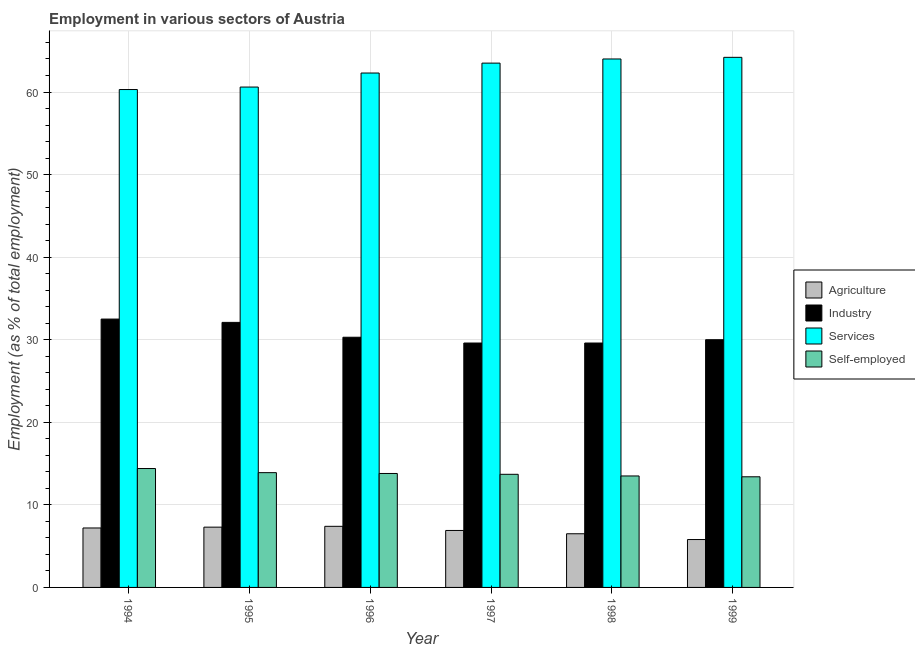How many different coloured bars are there?
Offer a terse response. 4. How many groups of bars are there?
Your answer should be compact. 6. How many bars are there on the 4th tick from the left?
Your response must be concise. 4. How many bars are there on the 4th tick from the right?
Your answer should be compact. 4. What is the label of the 4th group of bars from the left?
Your answer should be compact. 1997. In how many cases, is the number of bars for a given year not equal to the number of legend labels?
Make the answer very short. 0. What is the percentage of workers in agriculture in 1998?
Your response must be concise. 6.5. Across all years, what is the maximum percentage of workers in services?
Make the answer very short. 64.2. Across all years, what is the minimum percentage of workers in services?
Offer a very short reply. 60.3. In which year was the percentage of workers in industry maximum?
Your answer should be compact. 1994. What is the total percentage of workers in agriculture in the graph?
Your answer should be very brief. 41.1. What is the difference between the percentage of self employed workers in 1994 and that in 1995?
Give a very brief answer. 0.5. What is the difference between the percentage of workers in agriculture in 1998 and the percentage of workers in industry in 1999?
Your response must be concise. 0.7. What is the average percentage of workers in industry per year?
Provide a succinct answer. 30.68. What is the ratio of the percentage of workers in industry in 1995 to that in 1997?
Provide a short and direct response. 1.08. Is the percentage of workers in industry in 1996 less than that in 1999?
Make the answer very short. No. What is the difference between the highest and the second highest percentage of workers in agriculture?
Provide a short and direct response. 0.1. Is it the case that in every year, the sum of the percentage of workers in industry and percentage of self employed workers is greater than the sum of percentage of workers in agriculture and percentage of workers in services?
Ensure brevity in your answer.  No. What does the 2nd bar from the left in 1998 represents?
Ensure brevity in your answer.  Industry. What does the 4th bar from the right in 1998 represents?
Offer a very short reply. Agriculture. Is it the case that in every year, the sum of the percentage of workers in agriculture and percentage of workers in industry is greater than the percentage of workers in services?
Offer a terse response. No. How many bars are there?
Give a very brief answer. 24. How many years are there in the graph?
Offer a terse response. 6. What is the difference between two consecutive major ticks on the Y-axis?
Your answer should be very brief. 10. Are the values on the major ticks of Y-axis written in scientific E-notation?
Keep it short and to the point. No. Does the graph contain grids?
Give a very brief answer. Yes. Where does the legend appear in the graph?
Give a very brief answer. Center right. How many legend labels are there?
Give a very brief answer. 4. What is the title of the graph?
Provide a short and direct response. Employment in various sectors of Austria. What is the label or title of the Y-axis?
Offer a very short reply. Employment (as % of total employment). What is the Employment (as % of total employment) in Agriculture in 1994?
Give a very brief answer. 7.2. What is the Employment (as % of total employment) of Industry in 1994?
Offer a terse response. 32.5. What is the Employment (as % of total employment) in Services in 1994?
Provide a short and direct response. 60.3. What is the Employment (as % of total employment) in Self-employed in 1994?
Make the answer very short. 14.4. What is the Employment (as % of total employment) of Agriculture in 1995?
Keep it short and to the point. 7.3. What is the Employment (as % of total employment) in Industry in 1995?
Your answer should be compact. 32.1. What is the Employment (as % of total employment) of Services in 1995?
Your response must be concise. 60.6. What is the Employment (as % of total employment) in Self-employed in 1995?
Give a very brief answer. 13.9. What is the Employment (as % of total employment) in Agriculture in 1996?
Offer a very short reply. 7.4. What is the Employment (as % of total employment) of Industry in 1996?
Give a very brief answer. 30.3. What is the Employment (as % of total employment) in Services in 1996?
Provide a succinct answer. 62.3. What is the Employment (as % of total employment) in Self-employed in 1996?
Your response must be concise. 13.8. What is the Employment (as % of total employment) in Agriculture in 1997?
Keep it short and to the point. 6.9. What is the Employment (as % of total employment) in Industry in 1997?
Provide a short and direct response. 29.6. What is the Employment (as % of total employment) in Services in 1997?
Offer a terse response. 63.5. What is the Employment (as % of total employment) of Self-employed in 1997?
Keep it short and to the point. 13.7. What is the Employment (as % of total employment) of Industry in 1998?
Provide a succinct answer. 29.6. What is the Employment (as % of total employment) in Agriculture in 1999?
Your answer should be very brief. 5.8. What is the Employment (as % of total employment) in Industry in 1999?
Provide a succinct answer. 30. What is the Employment (as % of total employment) of Services in 1999?
Your response must be concise. 64.2. What is the Employment (as % of total employment) of Self-employed in 1999?
Offer a very short reply. 13.4. Across all years, what is the maximum Employment (as % of total employment) in Agriculture?
Provide a short and direct response. 7.4. Across all years, what is the maximum Employment (as % of total employment) of Industry?
Ensure brevity in your answer.  32.5. Across all years, what is the maximum Employment (as % of total employment) in Services?
Provide a short and direct response. 64.2. Across all years, what is the maximum Employment (as % of total employment) of Self-employed?
Provide a short and direct response. 14.4. Across all years, what is the minimum Employment (as % of total employment) of Agriculture?
Provide a succinct answer. 5.8. Across all years, what is the minimum Employment (as % of total employment) of Industry?
Provide a short and direct response. 29.6. Across all years, what is the minimum Employment (as % of total employment) of Services?
Ensure brevity in your answer.  60.3. Across all years, what is the minimum Employment (as % of total employment) in Self-employed?
Offer a terse response. 13.4. What is the total Employment (as % of total employment) in Agriculture in the graph?
Ensure brevity in your answer.  41.1. What is the total Employment (as % of total employment) in Industry in the graph?
Offer a very short reply. 184.1. What is the total Employment (as % of total employment) of Services in the graph?
Your response must be concise. 374.9. What is the total Employment (as % of total employment) in Self-employed in the graph?
Offer a terse response. 82.7. What is the difference between the Employment (as % of total employment) in Agriculture in 1994 and that in 1995?
Keep it short and to the point. -0.1. What is the difference between the Employment (as % of total employment) in Services in 1994 and that in 1995?
Your answer should be very brief. -0.3. What is the difference between the Employment (as % of total employment) of Agriculture in 1994 and that in 1996?
Offer a terse response. -0.2. What is the difference between the Employment (as % of total employment) of Services in 1994 and that in 1996?
Your answer should be compact. -2. What is the difference between the Employment (as % of total employment) of Industry in 1994 and that in 1997?
Offer a very short reply. 2.9. What is the difference between the Employment (as % of total employment) in Services in 1994 and that in 1997?
Your response must be concise. -3.2. What is the difference between the Employment (as % of total employment) in Self-employed in 1994 and that in 1997?
Offer a terse response. 0.7. What is the difference between the Employment (as % of total employment) in Industry in 1994 and that in 1999?
Keep it short and to the point. 2.5. What is the difference between the Employment (as % of total employment) of Services in 1994 and that in 1999?
Make the answer very short. -3.9. What is the difference between the Employment (as % of total employment) of Self-employed in 1994 and that in 1999?
Give a very brief answer. 1. What is the difference between the Employment (as % of total employment) in Services in 1995 and that in 1996?
Provide a succinct answer. -1.7. What is the difference between the Employment (as % of total employment) in Self-employed in 1995 and that in 1996?
Offer a terse response. 0.1. What is the difference between the Employment (as % of total employment) of Services in 1995 and that in 1997?
Make the answer very short. -2.9. What is the difference between the Employment (as % of total employment) of Services in 1995 and that in 1998?
Give a very brief answer. -3.4. What is the difference between the Employment (as % of total employment) in Agriculture in 1995 and that in 1999?
Your answer should be compact. 1.5. What is the difference between the Employment (as % of total employment) in Self-employed in 1995 and that in 1999?
Keep it short and to the point. 0.5. What is the difference between the Employment (as % of total employment) in Agriculture in 1996 and that in 1997?
Offer a very short reply. 0.5. What is the difference between the Employment (as % of total employment) of Agriculture in 1996 and that in 1998?
Make the answer very short. 0.9. What is the difference between the Employment (as % of total employment) in Self-employed in 1996 and that in 1998?
Offer a very short reply. 0.3. What is the difference between the Employment (as % of total employment) of Agriculture in 1996 and that in 1999?
Provide a short and direct response. 1.6. What is the difference between the Employment (as % of total employment) in Services in 1996 and that in 1999?
Your response must be concise. -1.9. What is the difference between the Employment (as % of total employment) of Self-employed in 1997 and that in 1998?
Give a very brief answer. 0.2. What is the difference between the Employment (as % of total employment) of Agriculture in 1997 and that in 1999?
Your answer should be very brief. 1.1. What is the difference between the Employment (as % of total employment) of Industry in 1997 and that in 1999?
Offer a very short reply. -0.4. What is the difference between the Employment (as % of total employment) of Industry in 1998 and that in 1999?
Offer a terse response. -0.4. What is the difference between the Employment (as % of total employment) in Self-employed in 1998 and that in 1999?
Give a very brief answer. 0.1. What is the difference between the Employment (as % of total employment) of Agriculture in 1994 and the Employment (as % of total employment) of Industry in 1995?
Give a very brief answer. -24.9. What is the difference between the Employment (as % of total employment) in Agriculture in 1994 and the Employment (as % of total employment) in Services in 1995?
Provide a short and direct response. -53.4. What is the difference between the Employment (as % of total employment) of Industry in 1994 and the Employment (as % of total employment) of Services in 1995?
Your response must be concise. -28.1. What is the difference between the Employment (as % of total employment) in Industry in 1994 and the Employment (as % of total employment) in Self-employed in 1995?
Your answer should be very brief. 18.6. What is the difference between the Employment (as % of total employment) in Services in 1994 and the Employment (as % of total employment) in Self-employed in 1995?
Ensure brevity in your answer.  46.4. What is the difference between the Employment (as % of total employment) of Agriculture in 1994 and the Employment (as % of total employment) of Industry in 1996?
Provide a short and direct response. -23.1. What is the difference between the Employment (as % of total employment) of Agriculture in 1994 and the Employment (as % of total employment) of Services in 1996?
Keep it short and to the point. -55.1. What is the difference between the Employment (as % of total employment) in Industry in 1994 and the Employment (as % of total employment) in Services in 1996?
Make the answer very short. -29.8. What is the difference between the Employment (as % of total employment) of Industry in 1994 and the Employment (as % of total employment) of Self-employed in 1996?
Give a very brief answer. 18.7. What is the difference between the Employment (as % of total employment) in Services in 1994 and the Employment (as % of total employment) in Self-employed in 1996?
Your response must be concise. 46.5. What is the difference between the Employment (as % of total employment) of Agriculture in 1994 and the Employment (as % of total employment) of Industry in 1997?
Provide a succinct answer. -22.4. What is the difference between the Employment (as % of total employment) of Agriculture in 1994 and the Employment (as % of total employment) of Services in 1997?
Provide a short and direct response. -56.3. What is the difference between the Employment (as % of total employment) in Industry in 1994 and the Employment (as % of total employment) in Services in 1997?
Keep it short and to the point. -31. What is the difference between the Employment (as % of total employment) in Industry in 1994 and the Employment (as % of total employment) in Self-employed in 1997?
Offer a very short reply. 18.8. What is the difference between the Employment (as % of total employment) in Services in 1994 and the Employment (as % of total employment) in Self-employed in 1997?
Ensure brevity in your answer.  46.6. What is the difference between the Employment (as % of total employment) in Agriculture in 1994 and the Employment (as % of total employment) in Industry in 1998?
Your answer should be compact. -22.4. What is the difference between the Employment (as % of total employment) in Agriculture in 1994 and the Employment (as % of total employment) in Services in 1998?
Your answer should be very brief. -56.8. What is the difference between the Employment (as % of total employment) of Industry in 1994 and the Employment (as % of total employment) of Services in 1998?
Provide a succinct answer. -31.5. What is the difference between the Employment (as % of total employment) of Services in 1994 and the Employment (as % of total employment) of Self-employed in 1998?
Provide a short and direct response. 46.8. What is the difference between the Employment (as % of total employment) in Agriculture in 1994 and the Employment (as % of total employment) in Industry in 1999?
Your answer should be very brief. -22.8. What is the difference between the Employment (as % of total employment) in Agriculture in 1994 and the Employment (as % of total employment) in Services in 1999?
Keep it short and to the point. -57. What is the difference between the Employment (as % of total employment) in Industry in 1994 and the Employment (as % of total employment) in Services in 1999?
Make the answer very short. -31.7. What is the difference between the Employment (as % of total employment) in Services in 1994 and the Employment (as % of total employment) in Self-employed in 1999?
Offer a terse response. 46.9. What is the difference between the Employment (as % of total employment) in Agriculture in 1995 and the Employment (as % of total employment) in Industry in 1996?
Make the answer very short. -23. What is the difference between the Employment (as % of total employment) in Agriculture in 1995 and the Employment (as % of total employment) in Services in 1996?
Provide a succinct answer. -55. What is the difference between the Employment (as % of total employment) of Agriculture in 1995 and the Employment (as % of total employment) of Self-employed in 1996?
Offer a very short reply. -6.5. What is the difference between the Employment (as % of total employment) of Industry in 1995 and the Employment (as % of total employment) of Services in 1996?
Offer a terse response. -30.2. What is the difference between the Employment (as % of total employment) of Industry in 1995 and the Employment (as % of total employment) of Self-employed in 1996?
Give a very brief answer. 18.3. What is the difference between the Employment (as % of total employment) in Services in 1995 and the Employment (as % of total employment) in Self-employed in 1996?
Make the answer very short. 46.8. What is the difference between the Employment (as % of total employment) in Agriculture in 1995 and the Employment (as % of total employment) in Industry in 1997?
Provide a short and direct response. -22.3. What is the difference between the Employment (as % of total employment) of Agriculture in 1995 and the Employment (as % of total employment) of Services in 1997?
Provide a succinct answer. -56.2. What is the difference between the Employment (as % of total employment) of Agriculture in 1995 and the Employment (as % of total employment) of Self-employed in 1997?
Make the answer very short. -6.4. What is the difference between the Employment (as % of total employment) of Industry in 1995 and the Employment (as % of total employment) of Services in 1997?
Offer a very short reply. -31.4. What is the difference between the Employment (as % of total employment) of Services in 1995 and the Employment (as % of total employment) of Self-employed in 1997?
Offer a terse response. 46.9. What is the difference between the Employment (as % of total employment) of Agriculture in 1995 and the Employment (as % of total employment) of Industry in 1998?
Give a very brief answer. -22.3. What is the difference between the Employment (as % of total employment) of Agriculture in 1995 and the Employment (as % of total employment) of Services in 1998?
Provide a succinct answer. -56.7. What is the difference between the Employment (as % of total employment) of Industry in 1995 and the Employment (as % of total employment) of Services in 1998?
Your answer should be very brief. -31.9. What is the difference between the Employment (as % of total employment) of Services in 1995 and the Employment (as % of total employment) of Self-employed in 1998?
Provide a short and direct response. 47.1. What is the difference between the Employment (as % of total employment) in Agriculture in 1995 and the Employment (as % of total employment) in Industry in 1999?
Provide a succinct answer. -22.7. What is the difference between the Employment (as % of total employment) of Agriculture in 1995 and the Employment (as % of total employment) of Services in 1999?
Provide a short and direct response. -56.9. What is the difference between the Employment (as % of total employment) in Agriculture in 1995 and the Employment (as % of total employment) in Self-employed in 1999?
Provide a succinct answer. -6.1. What is the difference between the Employment (as % of total employment) in Industry in 1995 and the Employment (as % of total employment) in Services in 1999?
Provide a short and direct response. -32.1. What is the difference between the Employment (as % of total employment) of Services in 1995 and the Employment (as % of total employment) of Self-employed in 1999?
Offer a very short reply. 47.2. What is the difference between the Employment (as % of total employment) in Agriculture in 1996 and the Employment (as % of total employment) in Industry in 1997?
Provide a succinct answer. -22.2. What is the difference between the Employment (as % of total employment) of Agriculture in 1996 and the Employment (as % of total employment) of Services in 1997?
Your response must be concise. -56.1. What is the difference between the Employment (as % of total employment) in Industry in 1996 and the Employment (as % of total employment) in Services in 1997?
Give a very brief answer. -33.2. What is the difference between the Employment (as % of total employment) in Services in 1996 and the Employment (as % of total employment) in Self-employed in 1997?
Keep it short and to the point. 48.6. What is the difference between the Employment (as % of total employment) in Agriculture in 1996 and the Employment (as % of total employment) in Industry in 1998?
Your answer should be very brief. -22.2. What is the difference between the Employment (as % of total employment) in Agriculture in 1996 and the Employment (as % of total employment) in Services in 1998?
Offer a very short reply. -56.6. What is the difference between the Employment (as % of total employment) of Agriculture in 1996 and the Employment (as % of total employment) of Self-employed in 1998?
Your answer should be compact. -6.1. What is the difference between the Employment (as % of total employment) of Industry in 1996 and the Employment (as % of total employment) of Services in 1998?
Your answer should be compact. -33.7. What is the difference between the Employment (as % of total employment) of Services in 1996 and the Employment (as % of total employment) of Self-employed in 1998?
Keep it short and to the point. 48.8. What is the difference between the Employment (as % of total employment) in Agriculture in 1996 and the Employment (as % of total employment) in Industry in 1999?
Offer a terse response. -22.6. What is the difference between the Employment (as % of total employment) in Agriculture in 1996 and the Employment (as % of total employment) in Services in 1999?
Provide a short and direct response. -56.8. What is the difference between the Employment (as % of total employment) in Agriculture in 1996 and the Employment (as % of total employment) in Self-employed in 1999?
Your answer should be very brief. -6. What is the difference between the Employment (as % of total employment) in Industry in 1996 and the Employment (as % of total employment) in Services in 1999?
Make the answer very short. -33.9. What is the difference between the Employment (as % of total employment) of Services in 1996 and the Employment (as % of total employment) of Self-employed in 1999?
Make the answer very short. 48.9. What is the difference between the Employment (as % of total employment) in Agriculture in 1997 and the Employment (as % of total employment) in Industry in 1998?
Offer a very short reply. -22.7. What is the difference between the Employment (as % of total employment) of Agriculture in 1997 and the Employment (as % of total employment) of Services in 1998?
Offer a terse response. -57.1. What is the difference between the Employment (as % of total employment) in Industry in 1997 and the Employment (as % of total employment) in Services in 1998?
Your answer should be compact. -34.4. What is the difference between the Employment (as % of total employment) in Industry in 1997 and the Employment (as % of total employment) in Self-employed in 1998?
Give a very brief answer. 16.1. What is the difference between the Employment (as % of total employment) of Services in 1997 and the Employment (as % of total employment) of Self-employed in 1998?
Provide a succinct answer. 50. What is the difference between the Employment (as % of total employment) in Agriculture in 1997 and the Employment (as % of total employment) in Industry in 1999?
Ensure brevity in your answer.  -23.1. What is the difference between the Employment (as % of total employment) of Agriculture in 1997 and the Employment (as % of total employment) of Services in 1999?
Provide a succinct answer. -57.3. What is the difference between the Employment (as % of total employment) of Agriculture in 1997 and the Employment (as % of total employment) of Self-employed in 1999?
Offer a terse response. -6.5. What is the difference between the Employment (as % of total employment) of Industry in 1997 and the Employment (as % of total employment) of Services in 1999?
Offer a very short reply. -34.6. What is the difference between the Employment (as % of total employment) in Industry in 1997 and the Employment (as % of total employment) in Self-employed in 1999?
Give a very brief answer. 16.2. What is the difference between the Employment (as % of total employment) of Services in 1997 and the Employment (as % of total employment) of Self-employed in 1999?
Your response must be concise. 50.1. What is the difference between the Employment (as % of total employment) in Agriculture in 1998 and the Employment (as % of total employment) in Industry in 1999?
Your answer should be compact. -23.5. What is the difference between the Employment (as % of total employment) of Agriculture in 1998 and the Employment (as % of total employment) of Services in 1999?
Offer a very short reply. -57.7. What is the difference between the Employment (as % of total employment) in Industry in 1998 and the Employment (as % of total employment) in Services in 1999?
Give a very brief answer. -34.6. What is the difference between the Employment (as % of total employment) of Industry in 1998 and the Employment (as % of total employment) of Self-employed in 1999?
Keep it short and to the point. 16.2. What is the difference between the Employment (as % of total employment) of Services in 1998 and the Employment (as % of total employment) of Self-employed in 1999?
Ensure brevity in your answer.  50.6. What is the average Employment (as % of total employment) in Agriculture per year?
Ensure brevity in your answer.  6.85. What is the average Employment (as % of total employment) in Industry per year?
Your response must be concise. 30.68. What is the average Employment (as % of total employment) of Services per year?
Your answer should be very brief. 62.48. What is the average Employment (as % of total employment) in Self-employed per year?
Your response must be concise. 13.78. In the year 1994, what is the difference between the Employment (as % of total employment) in Agriculture and Employment (as % of total employment) in Industry?
Provide a short and direct response. -25.3. In the year 1994, what is the difference between the Employment (as % of total employment) of Agriculture and Employment (as % of total employment) of Services?
Make the answer very short. -53.1. In the year 1994, what is the difference between the Employment (as % of total employment) in Agriculture and Employment (as % of total employment) in Self-employed?
Your response must be concise. -7.2. In the year 1994, what is the difference between the Employment (as % of total employment) in Industry and Employment (as % of total employment) in Services?
Keep it short and to the point. -27.8. In the year 1994, what is the difference between the Employment (as % of total employment) in Industry and Employment (as % of total employment) in Self-employed?
Keep it short and to the point. 18.1. In the year 1994, what is the difference between the Employment (as % of total employment) in Services and Employment (as % of total employment) in Self-employed?
Offer a terse response. 45.9. In the year 1995, what is the difference between the Employment (as % of total employment) in Agriculture and Employment (as % of total employment) in Industry?
Your answer should be very brief. -24.8. In the year 1995, what is the difference between the Employment (as % of total employment) in Agriculture and Employment (as % of total employment) in Services?
Make the answer very short. -53.3. In the year 1995, what is the difference between the Employment (as % of total employment) in Agriculture and Employment (as % of total employment) in Self-employed?
Provide a succinct answer. -6.6. In the year 1995, what is the difference between the Employment (as % of total employment) in Industry and Employment (as % of total employment) in Services?
Provide a short and direct response. -28.5. In the year 1995, what is the difference between the Employment (as % of total employment) in Industry and Employment (as % of total employment) in Self-employed?
Make the answer very short. 18.2. In the year 1995, what is the difference between the Employment (as % of total employment) of Services and Employment (as % of total employment) of Self-employed?
Your answer should be very brief. 46.7. In the year 1996, what is the difference between the Employment (as % of total employment) of Agriculture and Employment (as % of total employment) of Industry?
Make the answer very short. -22.9. In the year 1996, what is the difference between the Employment (as % of total employment) in Agriculture and Employment (as % of total employment) in Services?
Offer a terse response. -54.9. In the year 1996, what is the difference between the Employment (as % of total employment) of Agriculture and Employment (as % of total employment) of Self-employed?
Your response must be concise. -6.4. In the year 1996, what is the difference between the Employment (as % of total employment) in Industry and Employment (as % of total employment) in Services?
Offer a terse response. -32. In the year 1996, what is the difference between the Employment (as % of total employment) in Services and Employment (as % of total employment) in Self-employed?
Offer a terse response. 48.5. In the year 1997, what is the difference between the Employment (as % of total employment) of Agriculture and Employment (as % of total employment) of Industry?
Offer a very short reply. -22.7. In the year 1997, what is the difference between the Employment (as % of total employment) of Agriculture and Employment (as % of total employment) of Services?
Offer a very short reply. -56.6. In the year 1997, what is the difference between the Employment (as % of total employment) of Industry and Employment (as % of total employment) of Services?
Ensure brevity in your answer.  -33.9. In the year 1997, what is the difference between the Employment (as % of total employment) of Industry and Employment (as % of total employment) of Self-employed?
Give a very brief answer. 15.9. In the year 1997, what is the difference between the Employment (as % of total employment) in Services and Employment (as % of total employment) in Self-employed?
Your answer should be compact. 49.8. In the year 1998, what is the difference between the Employment (as % of total employment) of Agriculture and Employment (as % of total employment) of Industry?
Your answer should be very brief. -23.1. In the year 1998, what is the difference between the Employment (as % of total employment) in Agriculture and Employment (as % of total employment) in Services?
Your response must be concise. -57.5. In the year 1998, what is the difference between the Employment (as % of total employment) of Industry and Employment (as % of total employment) of Services?
Ensure brevity in your answer.  -34.4. In the year 1998, what is the difference between the Employment (as % of total employment) of Industry and Employment (as % of total employment) of Self-employed?
Offer a terse response. 16.1. In the year 1998, what is the difference between the Employment (as % of total employment) in Services and Employment (as % of total employment) in Self-employed?
Offer a terse response. 50.5. In the year 1999, what is the difference between the Employment (as % of total employment) of Agriculture and Employment (as % of total employment) of Industry?
Keep it short and to the point. -24.2. In the year 1999, what is the difference between the Employment (as % of total employment) of Agriculture and Employment (as % of total employment) of Services?
Your answer should be very brief. -58.4. In the year 1999, what is the difference between the Employment (as % of total employment) of Industry and Employment (as % of total employment) of Services?
Provide a short and direct response. -34.2. In the year 1999, what is the difference between the Employment (as % of total employment) of Industry and Employment (as % of total employment) of Self-employed?
Give a very brief answer. 16.6. In the year 1999, what is the difference between the Employment (as % of total employment) in Services and Employment (as % of total employment) in Self-employed?
Provide a short and direct response. 50.8. What is the ratio of the Employment (as % of total employment) in Agriculture in 1994 to that in 1995?
Offer a very short reply. 0.99. What is the ratio of the Employment (as % of total employment) of Industry in 1994 to that in 1995?
Make the answer very short. 1.01. What is the ratio of the Employment (as % of total employment) in Services in 1994 to that in 1995?
Provide a short and direct response. 0.99. What is the ratio of the Employment (as % of total employment) of Self-employed in 1994 to that in 1995?
Provide a succinct answer. 1.04. What is the ratio of the Employment (as % of total employment) in Industry in 1994 to that in 1996?
Provide a succinct answer. 1.07. What is the ratio of the Employment (as % of total employment) in Services in 1994 to that in 1996?
Your answer should be very brief. 0.97. What is the ratio of the Employment (as % of total employment) in Self-employed in 1994 to that in 1996?
Ensure brevity in your answer.  1.04. What is the ratio of the Employment (as % of total employment) in Agriculture in 1994 to that in 1997?
Provide a short and direct response. 1.04. What is the ratio of the Employment (as % of total employment) of Industry in 1994 to that in 1997?
Provide a short and direct response. 1.1. What is the ratio of the Employment (as % of total employment) in Services in 1994 to that in 1997?
Offer a very short reply. 0.95. What is the ratio of the Employment (as % of total employment) of Self-employed in 1994 to that in 1997?
Keep it short and to the point. 1.05. What is the ratio of the Employment (as % of total employment) of Agriculture in 1994 to that in 1998?
Give a very brief answer. 1.11. What is the ratio of the Employment (as % of total employment) in Industry in 1994 to that in 1998?
Make the answer very short. 1.1. What is the ratio of the Employment (as % of total employment) in Services in 1994 to that in 1998?
Make the answer very short. 0.94. What is the ratio of the Employment (as % of total employment) in Self-employed in 1994 to that in 1998?
Offer a very short reply. 1.07. What is the ratio of the Employment (as % of total employment) of Agriculture in 1994 to that in 1999?
Keep it short and to the point. 1.24. What is the ratio of the Employment (as % of total employment) in Industry in 1994 to that in 1999?
Provide a short and direct response. 1.08. What is the ratio of the Employment (as % of total employment) in Services in 1994 to that in 1999?
Your answer should be compact. 0.94. What is the ratio of the Employment (as % of total employment) of Self-employed in 1994 to that in 1999?
Ensure brevity in your answer.  1.07. What is the ratio of the Employment (as % of total employment) in Agriculture in 1995 to that in 1996?
Give a very brief answer. 0.99. What is the ratio of the Employment (as % of total employment) in Industry in 1995 to that in 1996?
Give a very brief answer. 1.06. What is the ratio of the Employment (as % of total employment) of Services in 1995 to that in 1996?
Keep it short and to the point. 0.97. What is the ratio of the Employment (as % of total employment) in Self-employed in 1995 to that in 1996?
Keep it short and to the point. 1.01. What is the ratio of the Employment (as % of total employment) of Agriculture in 1995 to that in 1997?
Your answer should be very brief. 1.06. What is the ratio of the Employment (as % of total employment) in Industry in 1995 to that in 1997?
Offer a terse response. 1.08. What is the ratio of the Employment (as % of total employment) in Services in 1995 to that in 1997?
Ensure brevity in your answer.  0.95. What is the ratio of the Employment (as % of total employment) of Self-employed in 1995 to that in 1997?
Ensure brevity in your answer.  1.01. What is the ratio of the Employment (as % of total employment) of Agriculture in 1995 to that in 1998?
Offer a terse response. 1.12. What is the ratio of the Employment (as % of total employment) in Industry in 1995 to that in 1998?
Provide a succinct answer. 1.08. What is the ratio of the Employment (as % of total employment) in Services in 1995 to that in 1998?
Your response must be concise. 0.95. What is the ratio of the Employment (as % of total employment) in Self-employed in 1995 to that in 1998?
Provide a succinct answer. 1.03. What is the ratio of the Employment (as % of total employment) of Agriculture in 1995 to that in 1999?
Your response must be concise. 1.26. What is the ratio of the Employment (as % of total employment) of Industry in 1995 to that in 1999?
Your answer should be compact. 1.07. What is the ratio of the Employment (as % of total employment) of Services in 1995 to that in 1999?
Offer a terse response. 0.94. What is the ratio of the Employment (as % of total employment) of Self-employed in 1995 to that in 1999?
Offer a very short reply. 1.04. What is the ratio of the Employment (as % of total employment) in Agriculture in 1996 to that in 1997?
Keep it short and to the point. 1.07. What is the ratio of the Employment (as % of total employment) in Industry in 1996 to that in 1997?
Keep it short and to the point. 1.02. What is the ratio of the Employment (as % of total employment) of Services in 1996 to that in 1997?
Provide a succinct answer. 0.98. What is the ratio of the Employment (as % of total employment) in Self-employed in 1996 to that in 1997?
Provide a short and direct response. 1.01. What is the ratio of the Employment (as % of total employment) of Agriculture in 1996 to that in 1998?
Offer a very short reply. 1.14. What is the ratio of the Employment (as % of total employment) of Industry in 1996 to that in 1998?
Offer a terse response. 1.02. What is the ratio of the Employment (as % of total employment) in Services in 1996 to that in 1998?
Keep it short and to the point. 0.97. What is the ratio of the Employment (as % of total employment) of Self-employed in 1996 to that in 1998?
Offer a terse response. 1.02. What is the ratio of the Employment (as % of total employment) in Agriculture in 1996 to that in 1999?
Your answer should be compact. 1.28. What is the ratio of the Employment (as % of total employment) in Industry in 1996 to that in 1999?
Give a very brief answer. 1.01. What is the ratio of the Employment (as % of total employment) of Services in 1996 to that in 1999?
Keep it short and to the point. 0.97. What is the ratio of the Employment (as % of total employment) of Self-employed in 1996 to that in 1999?
Your answer should be very brief. 1.03. What is the ratio of the Employment (as % of total employment) in Agriculture in 1997 to that in 1998?
Ensure brevity in your answer.  1.06. What is the ratio of the Employment (as % of total employment) of Services in 1997 to that in 1998?
Provide a short and direct response. 0.99. What is the ratio of the Employment (as % of total employment) in Self-employed in 1997 to that in 1998?
Offer a terse response. 1.01. What is the ratio of the Employment (as % of total employment) of Agriculture in 1997 to that in 1999?
Make the answer very short. 1.19. What is the ratio of the Employment (as % of total employment) of Industry in 1997 to that in 1999?
Ensure brevity in your answer.  0.99. What is the ratio of the Employment (as % of total employment) of Self-employed in 1997 to that in 1999?
Give a very brief answer. 1.02. What is the ratio of the Employment (as % of total employment) of Agriculture in 1998 to that in 1999?
Give a very brief answer. 1.12. What is the ratio of the Employment (as % of total employment) in Industry in 1998 to that in 1999?
Your answer should be compact. 0.99. What is the ratio of the Employment (as % of total employment) of Self-employed in 1998 to that in 1999?
Provide a short and direct response. 1.01. What is the difference between the highest and the second highest Employment (as % of total employment) of Self-employed?
Provide a succinct answer. 0.5. What is the difference between the highest and the lowest Employment (as % of total employment) of Industry?
Your answer should be compact. 2.9. 